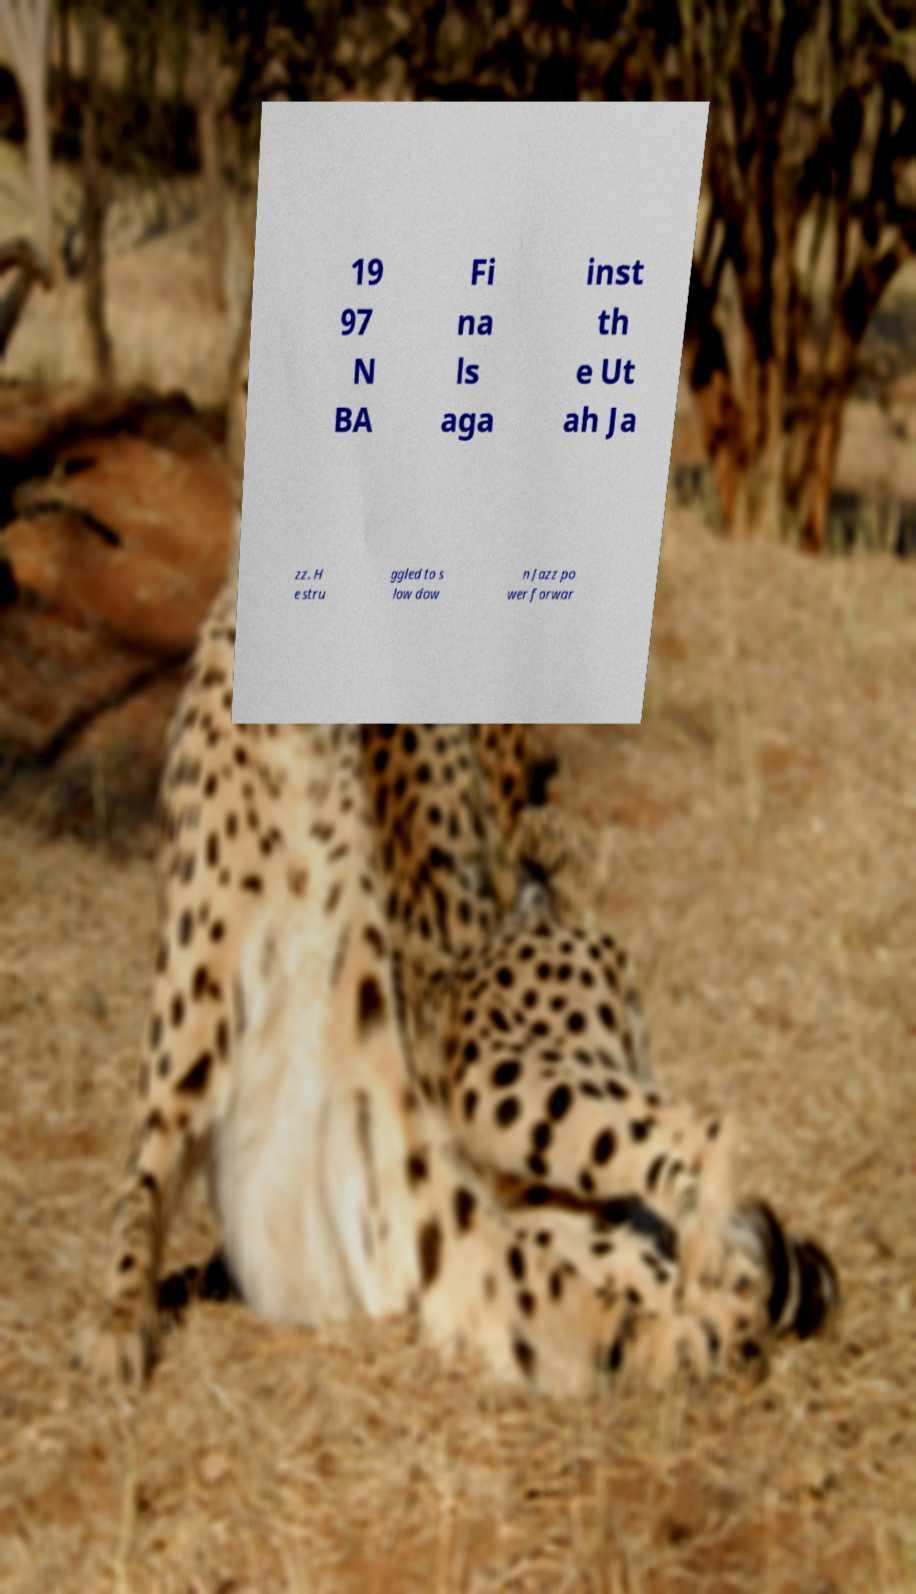Please read and relay the text visible in this image. What does it say? 19 97 N BA Fi na ls aga inst th e Ut ah Ja zz. H e stru ggled to s low dow n Jazz po wer forwar 